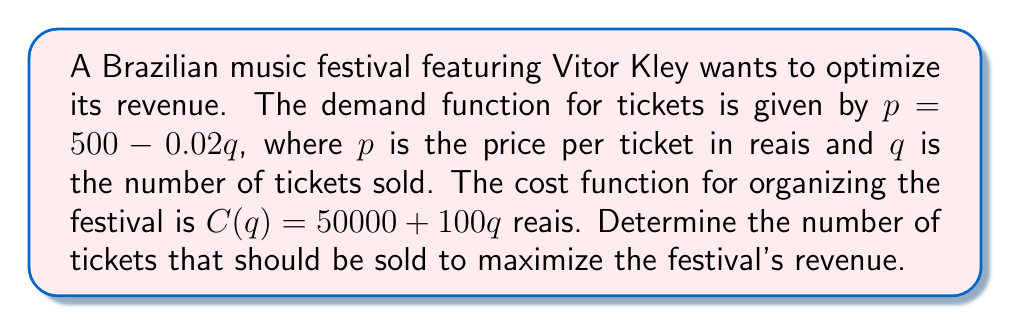Give your solution to this math problem. 1) First, let's define the revenue function $R(q)$:
   $R(q) = pq = (500 - 0.02q)q = 500q - 0.02q^2$

2) The profit function $P(q)$ is revenue minus cost:
   $P(q) = R(q) - C(q) = (500q - 0.02q^2) - (50000 + 100q)$
   $P(q) = 500q - 0.02q^2 - 50000 - 100q$
   $P(q) = 400q - 0.02q^2 - 50000$

3) To find the maximum profit, we need to find where $\frac{dP}{dq} = 0$:
   $\frac{dP}{dq} = 400 - 0.04q$

4) Set this equal to zero and solve for q:
   $400 - 0.04q = 0$
   $0.04q = 400$
   $q = 10000$

5) To confirm this is a maximum, check the second derivative:
   $\frac{d^2P}{dq^2} = -0.04 < 0$, confirming a maximum.

6) Therefore, the festival should sell 10,000 tickets to maximize revenue.

7) The optimal price can be found by substituting q back into the demand function:
   $p = 500 - 0.02(10000) = 300$ reais per ticket
Answer: 10,000 tickets 